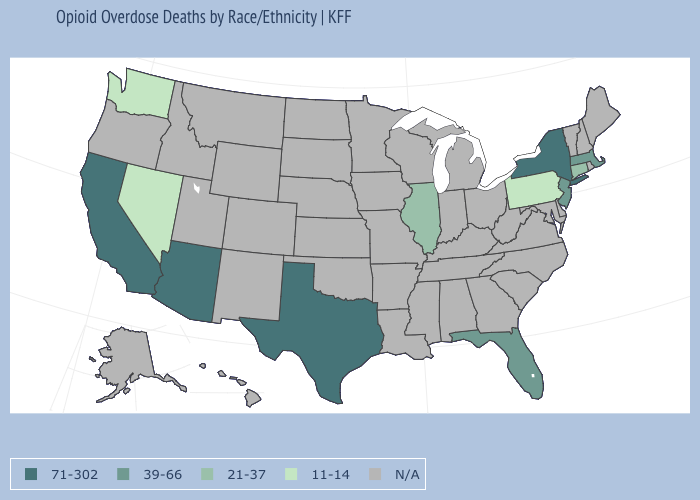Name the states that have a value in the range 11-14?
Write a very short answer. Nevada, Pennsylvania, Washington. Which states have the highest value in the USA?
Be succinct. Arizona, California, New York, Texas. Is the legend a continuous bar?
Give a very brief answer. No. Name the states that have a value in the range N/A?
Answer briefly. Alabama, Alaska, Arkansas, Colorado, Delaware, Georgia, Hawaii, Idaho, Indiana, Iowa, Kansas, Kentucky, Louisiana, Maine, Maryland, Michigan, Minnesota, Mississippi, Missouri, Montana, Nebraska, New Hampshire, New Mexico, North Carolina, North Dakota, Ohio, Oklahoma, Oregon, Rhode Island, South Carolina, South Dakota, Tennessee, Utah, Vermont, Virginia, West Virginia, Wisconsin, Wyoming. Which states have the lowest value in the Northeast?
Keep it brief. Pennsylvania. What is the highest value in states that border Maryland?
Answer briefly. 11-14. Does California have the lowest value in the West?
Answer briefly. No. What is the highest value in the USA?
Short answer required. 71-302. What is the value of Colorado?
Be succinct. N/A. Which states have the lowest value in the South?
Short answer required. Florida. Does Pennsylvania have the lowest value in the USA?
Keep it brief. Yes. 